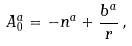Convert formula to latex. <formula><loc_0><loc_0><loc_500><loc_500>A _ { 0 } ^ { a } = - n ^ { a } + \frac { b ^ { a } } r \, ,</formula> 